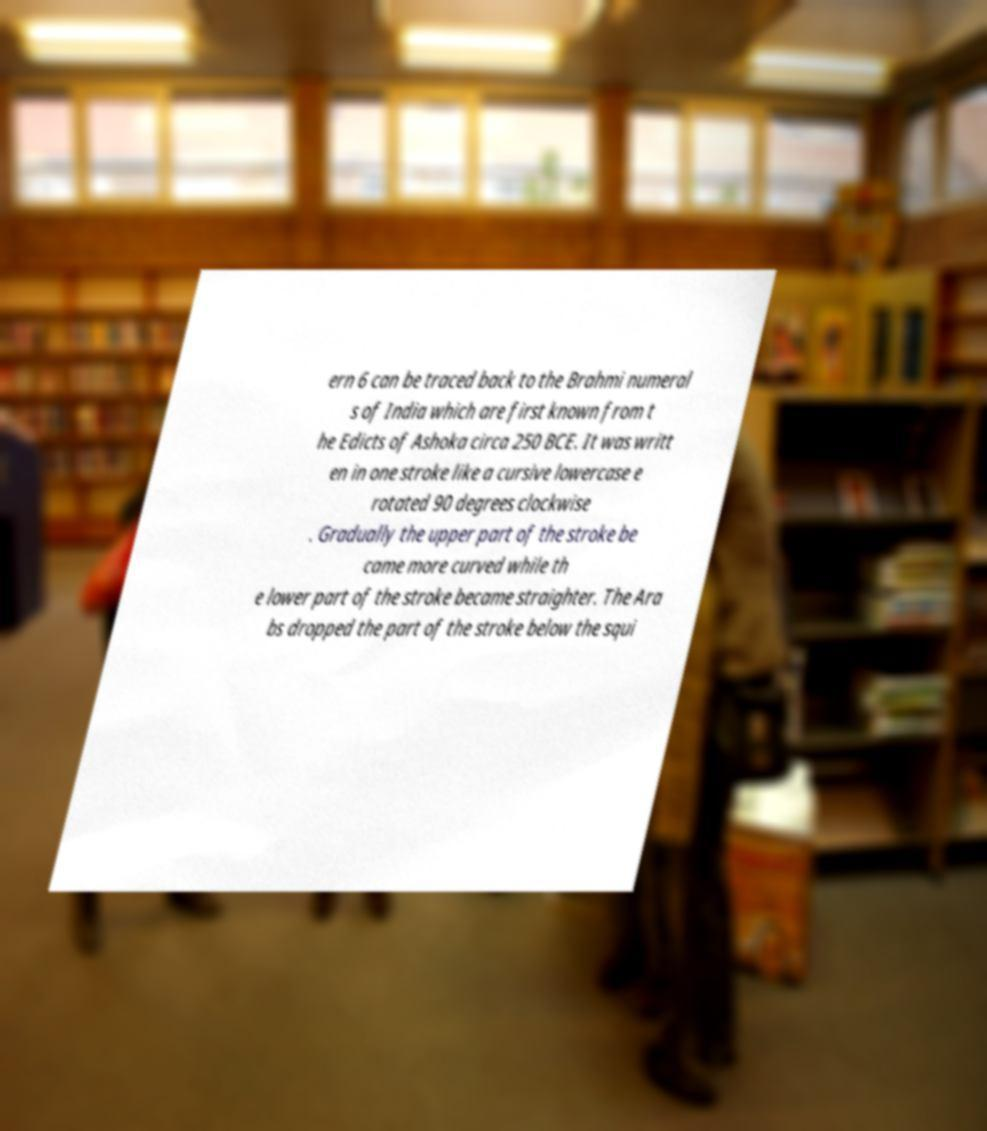Could you extract and type out the text from this image? ern 6 can be traced back to the Brahmi numeral s of India which are first known from t he Edicts of Ashoka circa 250 BCE. It was writt en in one stroke like a cursive lowercase e rotated 90 degrees clockwise . Gradually the upper part of the stroke be came more curved while th e lower part of the stroke became straighter. The Ara bs dropped the part of the stroke below the squi 